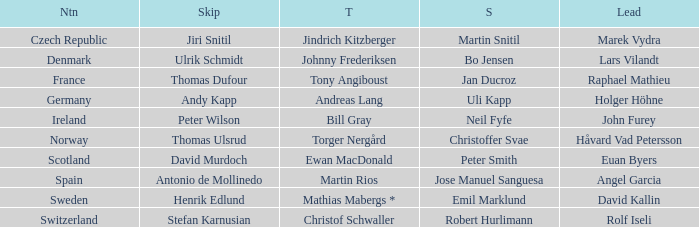Which Third has a Nation of scotland? Ewan MacDonald. 